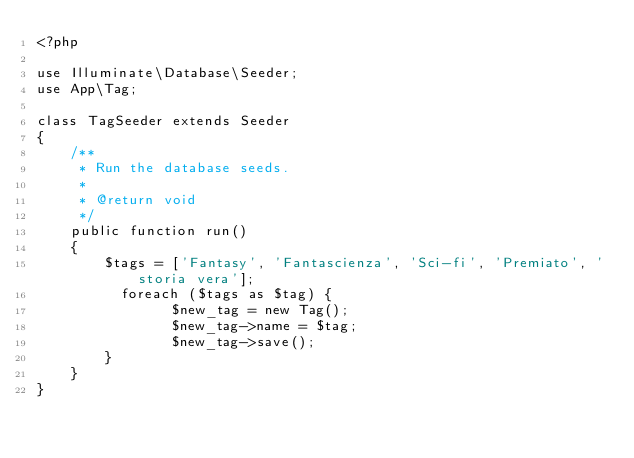Convert code to text. <code><loc_0><loc_0><loc_500><loc_500><_PHP_><?php

use Illuminate\Database\Seeder;
use App\Tag;

class TagSeeder extends Seeder
{
    /**
     * Run the database seeds.
     *
     * @return void
     */
    public function run()
    {
        $tags = ['Fantasy', 'Fantascienza', 'Sci-fi', 'Premiato', 'storia vera'];
	        foreach ($tags as $tag) {
                $new_tag = new Tag();
                $new_tag->name = $tag;
                $new_tag->save();
        }
    }
}
</code> 